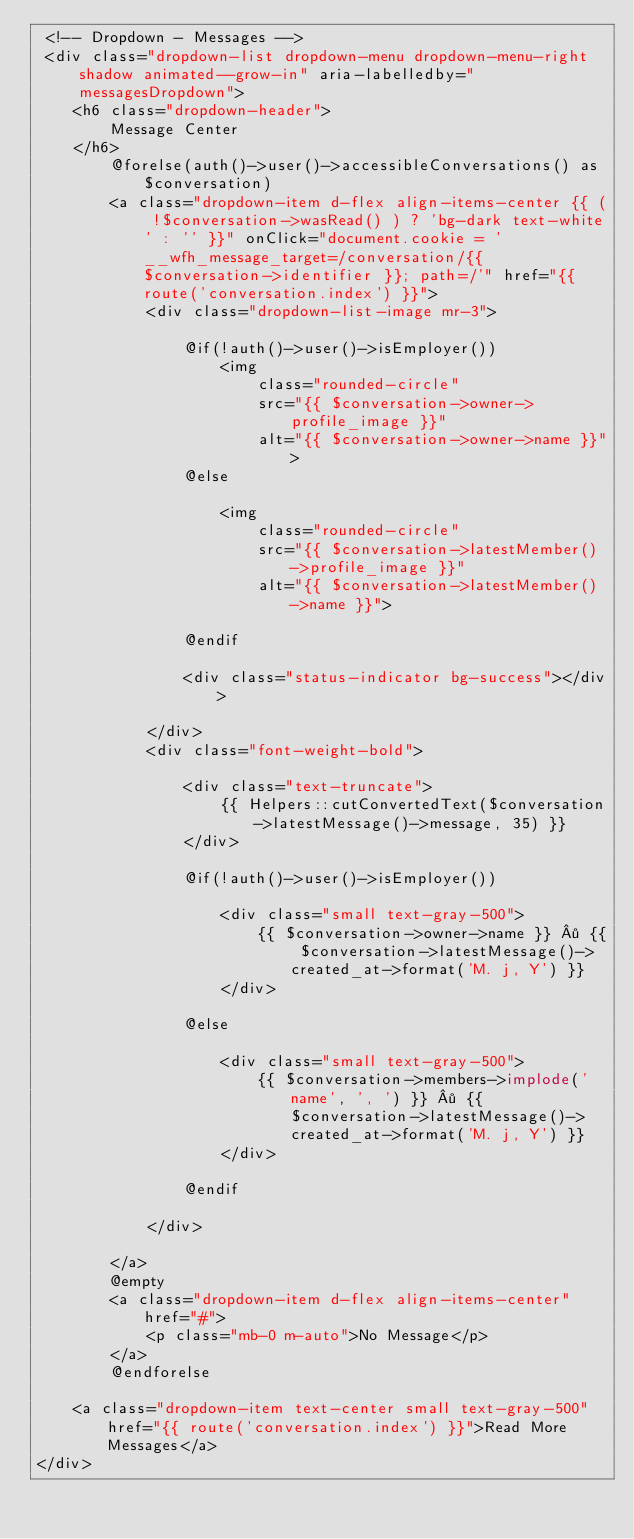<code> <loc_0><loc_0><loc_500><loc_500><_PHP_> <!-- Dropdown - Messages -->
 <div class="dropdown-list dropdown-menu dropdown-menu-right shadow animated--grow-in" aria-labelledby="messagesDropdown">
    <h6 class="dropdown-header">
        Message Center
    </h6>
        @forelse(auth()->user()->accessibleConversations() as $conversation)
        <a class="dropdown-item d-flex align-items-center {{ ( !$conversation->wasRead() ) ? 'bg-dark text-white' : '' }}" onClick="document.cookie = '__wfh_message_target=/conversation/{{ $conversation->identifier }}; path=/'" href="{{ route('conversation.index') }}">
            <div class="dropdown-list-image mr-3">

                @if(!auth()->user()->isEmployer())
                    <img 
                        class="rounded-circle" 
                        src="{{ $conversation->owner->profile_image }}" 
                        alt="{{ $conversation->owner->name }}">
                @else

                    <img 
                        class="rounded-circle" 
                        src="{{ $conversation->latestMember()->profile_image }}" 
                        alt="{{ $conversation->latestMember()->name }}">

                @endif

                <div class="status-indicator bg-success"></div>

            </div>
            <div class="font-weight-bold">

                <div class="text-truncate">
                    {{ Helpers::cutConvertedText($conversation->latestMessage()->message, 35) }}
                </div>

                @if(!auth()->user()->isEmployer())

                    <div class="small text-gray-500">
                        {{ $conversation->owner->name }} · {{ $conversation->latestMessage()->created_at->format('M. j, Y') }}
                    </div>

                @else

                    <div class="small text-gray-500">
                        {{ $conversation->members->implode('name', ', ') }} · {{ $conversation->latestMessage()->created_at->format('M. j, Y') }}
                    </div>

                @endif

            </div>

        </a>
        @empty
        <a class="dropdown-item d-flex align-items-center" href="#">
            <p class="mb-0 m-auto">No Message</p>
        </a>
        @endforelse
    
    <a class="dropdown-item text-center small text-gray-500" href="{{ route('conversation.index') }}">Read More Messages</a>
</div></code> 